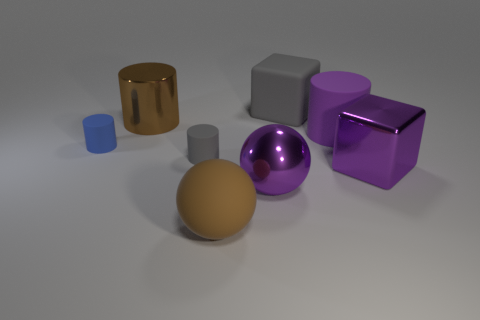Subtract all blue cylinders. How many cylinders are left? 3 Add 2 small gray matte cylinders. How many objects exist? 10 Subtract all purple blocks. How many blocks are left? 1 Subtract all blocks. How many objects are left? 6 Add 1 tiny blue cylinders. How many tiny blue cylinders exist? 2 Subtract 0 blue cubes. How many objects are left? 8 Subtract 2 blocks. How many blocks are left? 0 Subtract all gray cylinders. Subtract all brown blocks. How many cylinders are left? 3 Subtract all green cylinders. How many gray cubes are left? 1 Subtract all big brown metallic cylinders. Subtract all purple metal objects. How many objects are left? 5 